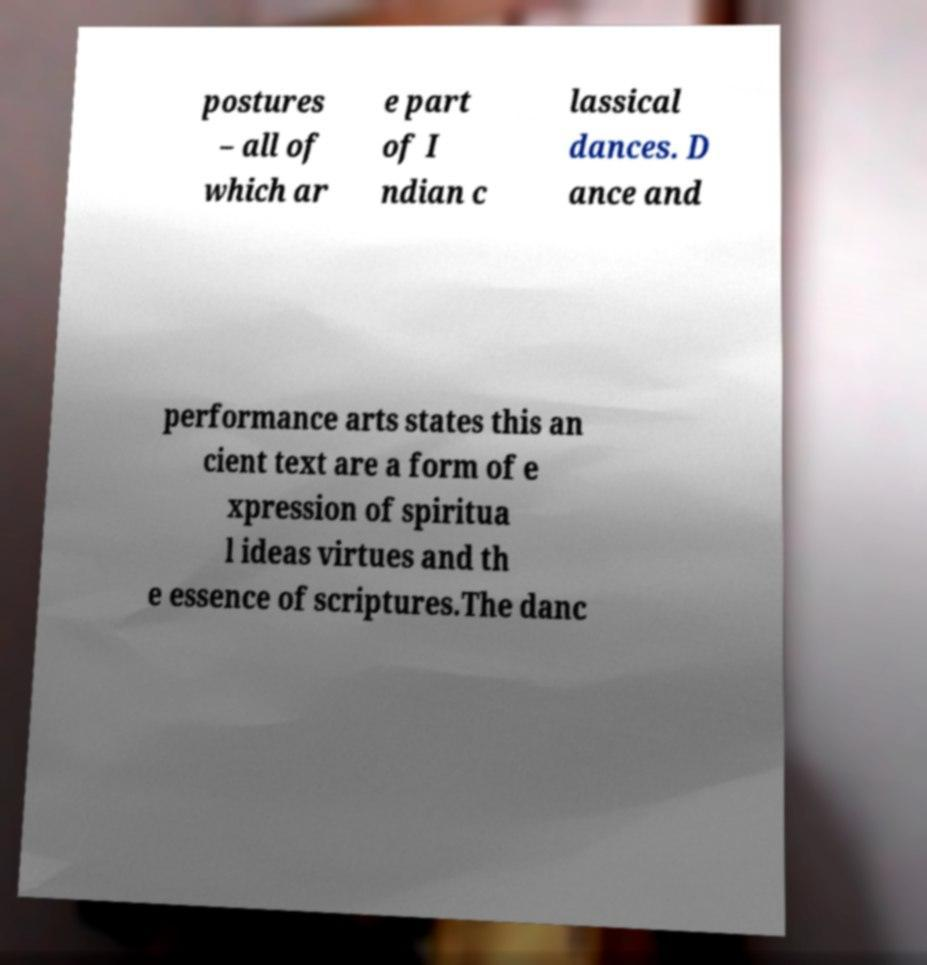Please identify and transcribe the text found in this image. postures – all of which ar e part of I ndian c lassical dances. D ance and performance arts states this an cient text are a form of e xpression of spiritua l ideas virtues and th e essence of scriptures.The danc 